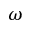Convert formula to latex. <formula><loc_0><loc_0><loc_500><loc_500>\omega</formula> 